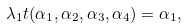<formula> <loc_0><loc_0><loc_500><loc_500>\lambda _ { 1 } t ( \alpha _ { 1 } , \alpha _ { 2 } , \alpha _ { 3 } , \alpha _ { 4 } ) = \alpha _ { 1 } ,</formula> 